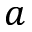Convert formula to latex. <formula><loc_0><loc_0><loc_500><loc_500>a</formula> 